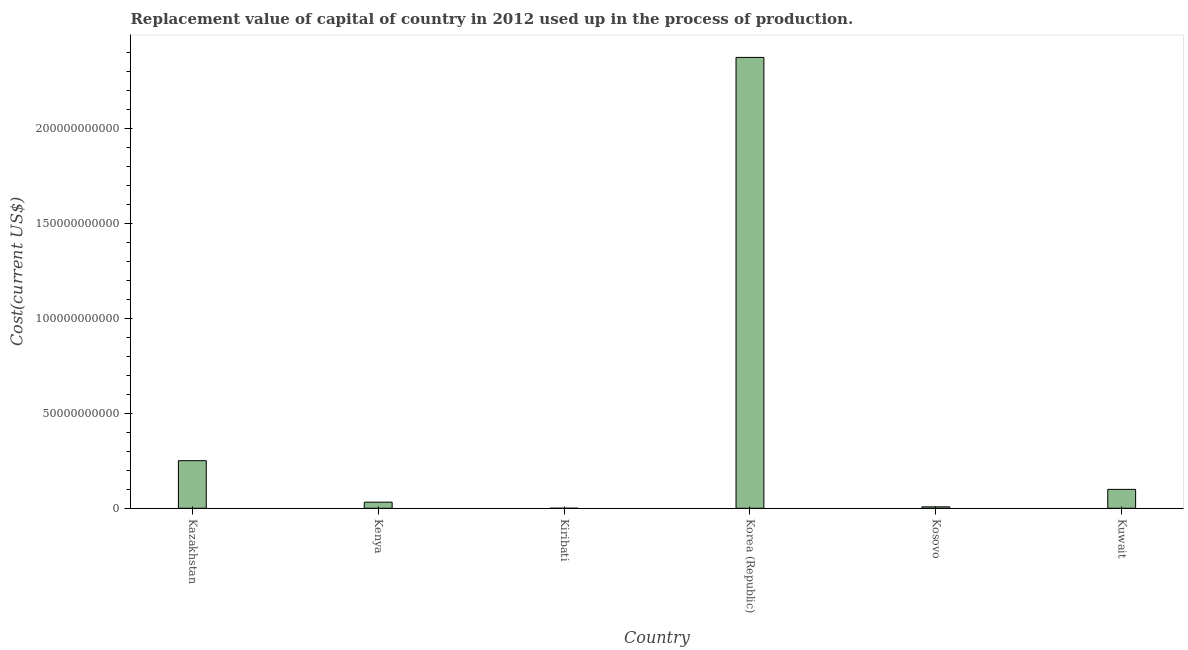Does the graph contain grids?
Your response must be concise. No. What is the title of the graph?
Keep it short and to the point. Replacement value of capital of country in 2012 used up in the process of production. What is the label or title of the Y-axis?
Your answer should be compact. Cost(current US$). What is the consumption of fixed capital in Kenya?
Make the answer very short. 3.20e+09. Across all countries, what is the maximum consumption of fixed capital?
Your answer should be compact. 2.37e+11. Across all countries, what is the minimum consumption of fixed capital?
Provide a succinct answer. 1.23e+07. In which country was the consumption of fixed capital maximum?
Your answer should be very brief. Korea (Republic). In which country was the consumption of fixed capital minimum?
Give a very brief answer. Kiribati. What is the sum of the consumption of fixed capital?
Provide a succinct answer. 2.76e+11. What is the difference between the consumption of fixed capital in Kenya and Kuwait?
Ensure brevity in your answer.  -6.74e+09. What is the average consumption of fixed capital per country?
Provide a short and direct response. 4.61e+1. What is the median consumption of fixed capital?
Offer a very short reply. 6.57e+09. In how many countries, is the consumption of fixed capital greater than 90000000000 US$?
Offer a very short reply. 1. What is the ratio of the consumption of fixed capital in Kenya to that in Kuwait?
Ensure brevity in your answer.  0.32. What is the difference between the highest and the second highest consumption of fixed capital?
Keep it short and to the point. 2.12e+11. Is the sum of the consumption of fixed capital in Kazakhstan and Korea (Republic) greater than the maximum consumption of fixed capital across all countries?
Your answer should be very brief. Yes. What is the difference between the highest and the lowest consumption of fixed capital?
Provide a succinct answer. 2.37e+11. In how many countries, is the consumption of fixed capital greater than the average consumption of fixed capital taken over all countries?
Offer a very short reply. 1. How many bars are there?
Your answer should be very brief. 6. What is the difference between two consecutive major ticks on the Y-axis?
Provide a succinct answer. 5.00e+1. What is the Cost(current US$) of Kazakhstan?
Your answer should be compact. 2.51e+1. What is the Cost(current US$) of Kenya?
Offer a terse response. 3.20e+09. What is the Cost(current US$) of Kiribati?
Your answer should be compact. 1.23e+07. What is the Cost(current US$) of Korea (Republic)?
Give a very brief answer. 2.37e+11. What is the Cost(current US$) of Kosovo?
Provide a short and direct response. 7.47e+08. What is the Cost(current US$) of Kuwait?
Your answer should be very brief. 9.94e+09. What is the difference between the Cost(current US$) in Kazakhstan and Kenya?
Make the answer very short. 2.19e+1. What is the difference between the Cost(current US$) in Kazakhstan and Kiribati?
Provide a short and direct response. 2.50e+1. What is the difference between the Cost(current US$) in Kazakhstan and Korea (Republic)?
Provide a short and direct response. -2.12e+11. What is the difference between the Cost(current US$) in Kazakhstan and Kosovo?
Your answer should be compact. 2.43e+1. What is the difference between the Cost(current US$) in Kazakhstan and Kuwait?
Offer a very short reply. 1.51e+1. What is the difference between the Cost(current US$) in Kenya and Kiribati?
Give a very brief answer. 3.19e+09. What is the difference between the Cost(current US$) in Kenya and Korea (Republic)?
Provide a succinct answer. -2.34e+11. What is the difference between the Cost(current US$) in Kenya and Kosovo?
Give a very brief answer. 2.46e+09. What is the difference between the Cost(current US$) in Kenya and Kuwait?
Make the answer very short. -6.74e+09. What is the difference between the Cost(current US$) in Kiribati and Korea (Republic)?
Your response must be concise. -2.37e+11. What is the difference between the Cost(current US$) in Kiribati and Kosovo?
Offer a terse response. -7.35e+08. What is the difference between the Cost(current US$) in Kiribati and Kuwait?
Keep it short and to the point. -9.93e+09. What is the difference between the Cost(current US$) in Korea (Republic) and Kosovo?
Give a very brief answer. 2.37e+11. What is the difference between the Cost(current US$) in Korea (Republic) and Kuwait?
Offer a terse response. 2.27e+11. What is the difference between the Cost(current US$) in Kosovo and Kuwait?
Keep it short and to the point. -9.20e+09. What is the ratio of the Cost(current US$) in Kazakhstan to that in Kenya?
Make the answer very short. 7.82. What is the ratio of the Cost(current US$) in Kazakhstan to that in Kiribati?
Your answer should be very brief. 2033.21. What is the ratio of the Cost(current US$) in Kazakhstan to that in Korea (Republic)?
Make the answer very short. 0.11. What is the ratio of the Cost(current US$) in Kazakhstan to that in Kosovo?
Give a very brief answer. 33.52. What is the ratio of the Cost(current US$) in Kazakhstan to that in Kuwait?
Provide a succinct answer. 2.52. What is the ratio of the Cost(current US$) in Kenya to that in Kiribati?
Give a very brief answer. 259.9. What is the ratio of the Cost(current US$) in Kenya to that in Korea (Republic)?
Offer a terse response. 0.01. What is the ratio of the Cost(current US$) in Kenya to that in Kosovo?
Provide a short and direct response. 4.29. What is the ratio of the Cost(current US$) in Kenya to that in Kuwait?
Ensure brevity in your answer.  0.32. What is the ratio of the Cost(current US$) in Kiribati to that in Kosovo?
Provide a short and direct response. 0.02. What is the ratio of the Cost(current US$) in Kiribati to that in Kuwait?
Your answer should be very brief. 0. What is the ratio of the Cost(current US$) in Korea (Republic) to that in Kosovo?
Offer a terse response. 317.62. What is the ratio of the Cost(current US$) in Korea (Republic) to that in Kuwait?
Make the answer very short. 23.87. What is the ratio of the Cost(current US$) in Kosovo to that in Kuwait?
Your answer should be very brief. 0.07. 